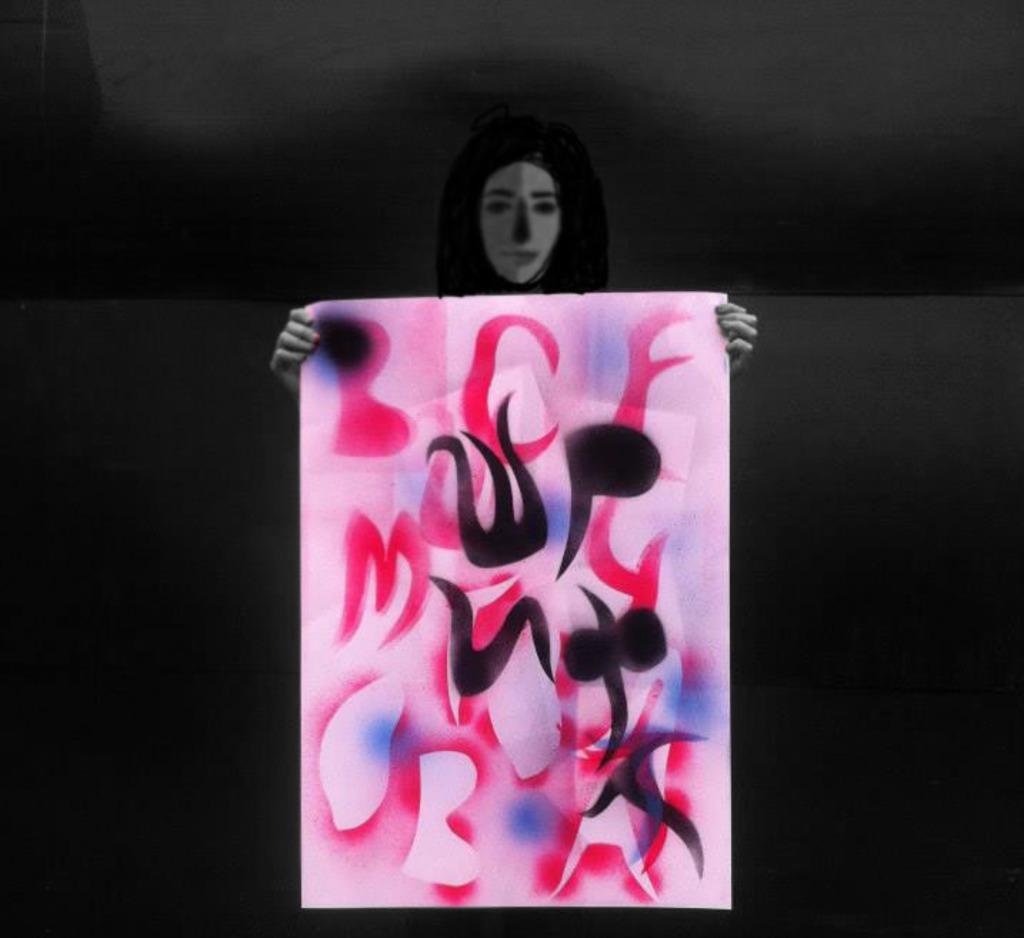What is the main subject of the image? There is a person in the image. What is the person holding in the image? The person is holding a poster. Can you describe the background of the image? The background of the image is dark. What type of knife is the person using to cut the spring in the image? There is no knife or spring present in the image; it only features a person holding a poster with a dark background. 